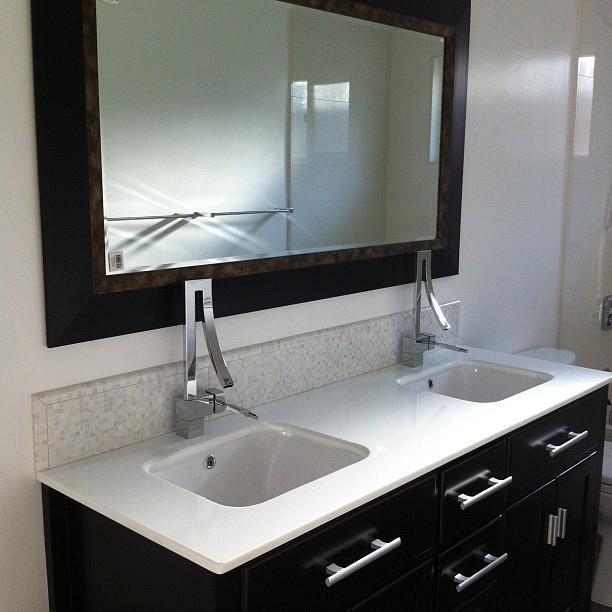How many sinks are there?
Give a very brief answer. 2. How many giraffes are there?
Give a very brief answer. 0. 